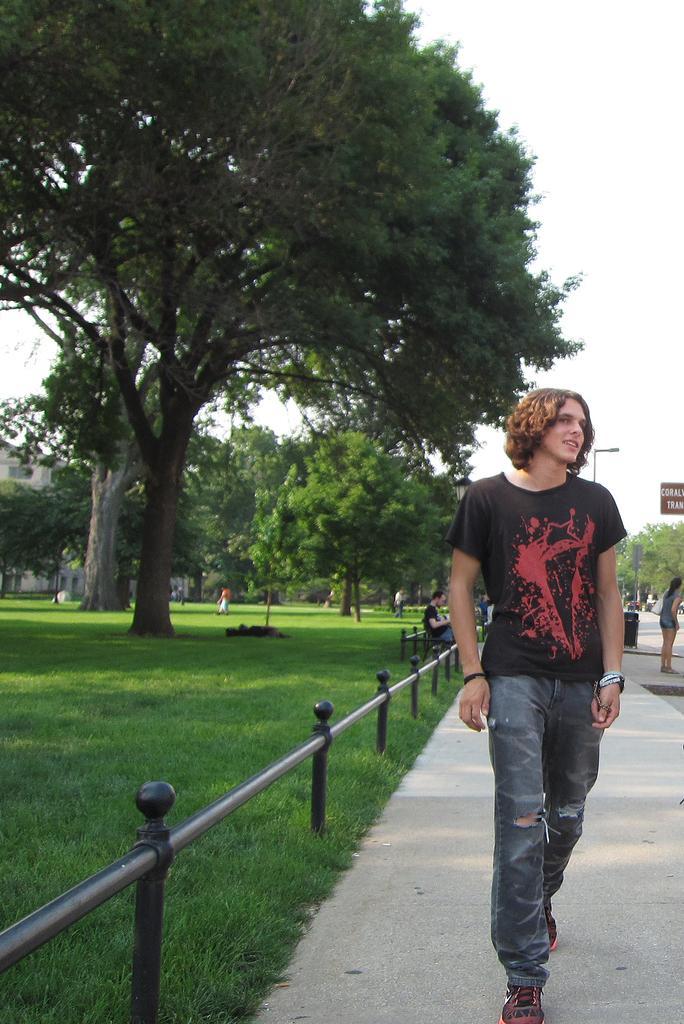Please provide a concise description of this image. In the foreground of this image, there is a man in black T shirt and blue jeans walking on side path. On right, there is a woman standing side to the road. On left, there are trees, grass and the sky on top. 